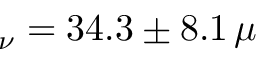<formula> <loc_0><loc_0><loc_500><loc_500>_ { \nu } = 3 4 . 3 \pm 8 . 1 \, \mu</formula> 